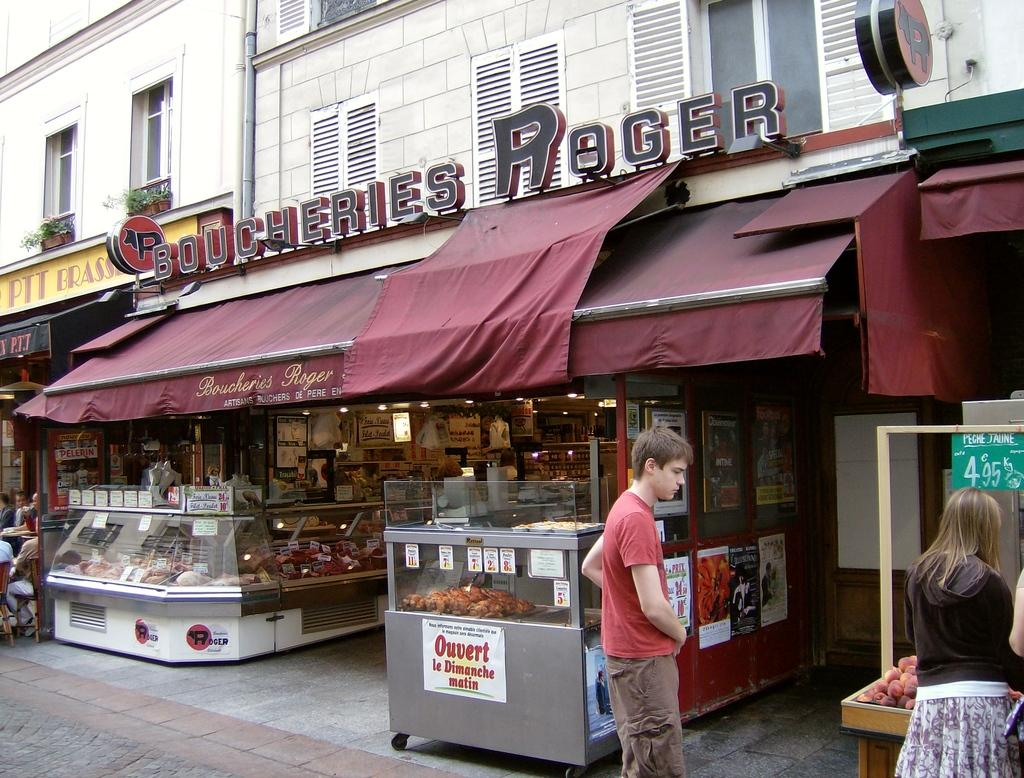<image>
Write a terse but informative summary of the picture. People shopping in front of a Boucheries Roger butcher shop 